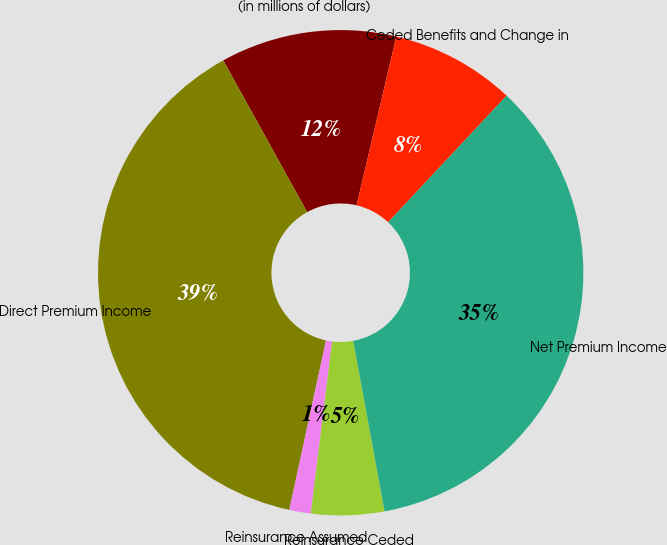Convert chart to OTSL. <chart><loc_0><loc_0><loc_500><loc_500><pie_chart><fcel>(in millions of dollars)<fcel>Direct Premium Income<fcel>Reinsurance Assumed<fcel>Reinsurance Ceded<fcel>Net Premium Income<fcel>Ceded Benefits and Change in<nl><fcel>11.72%<fcel>38.56%<fcel>1.43%<fcel>4.86%<fcel>35.13%<fcel>8.29%<nl></chart> 